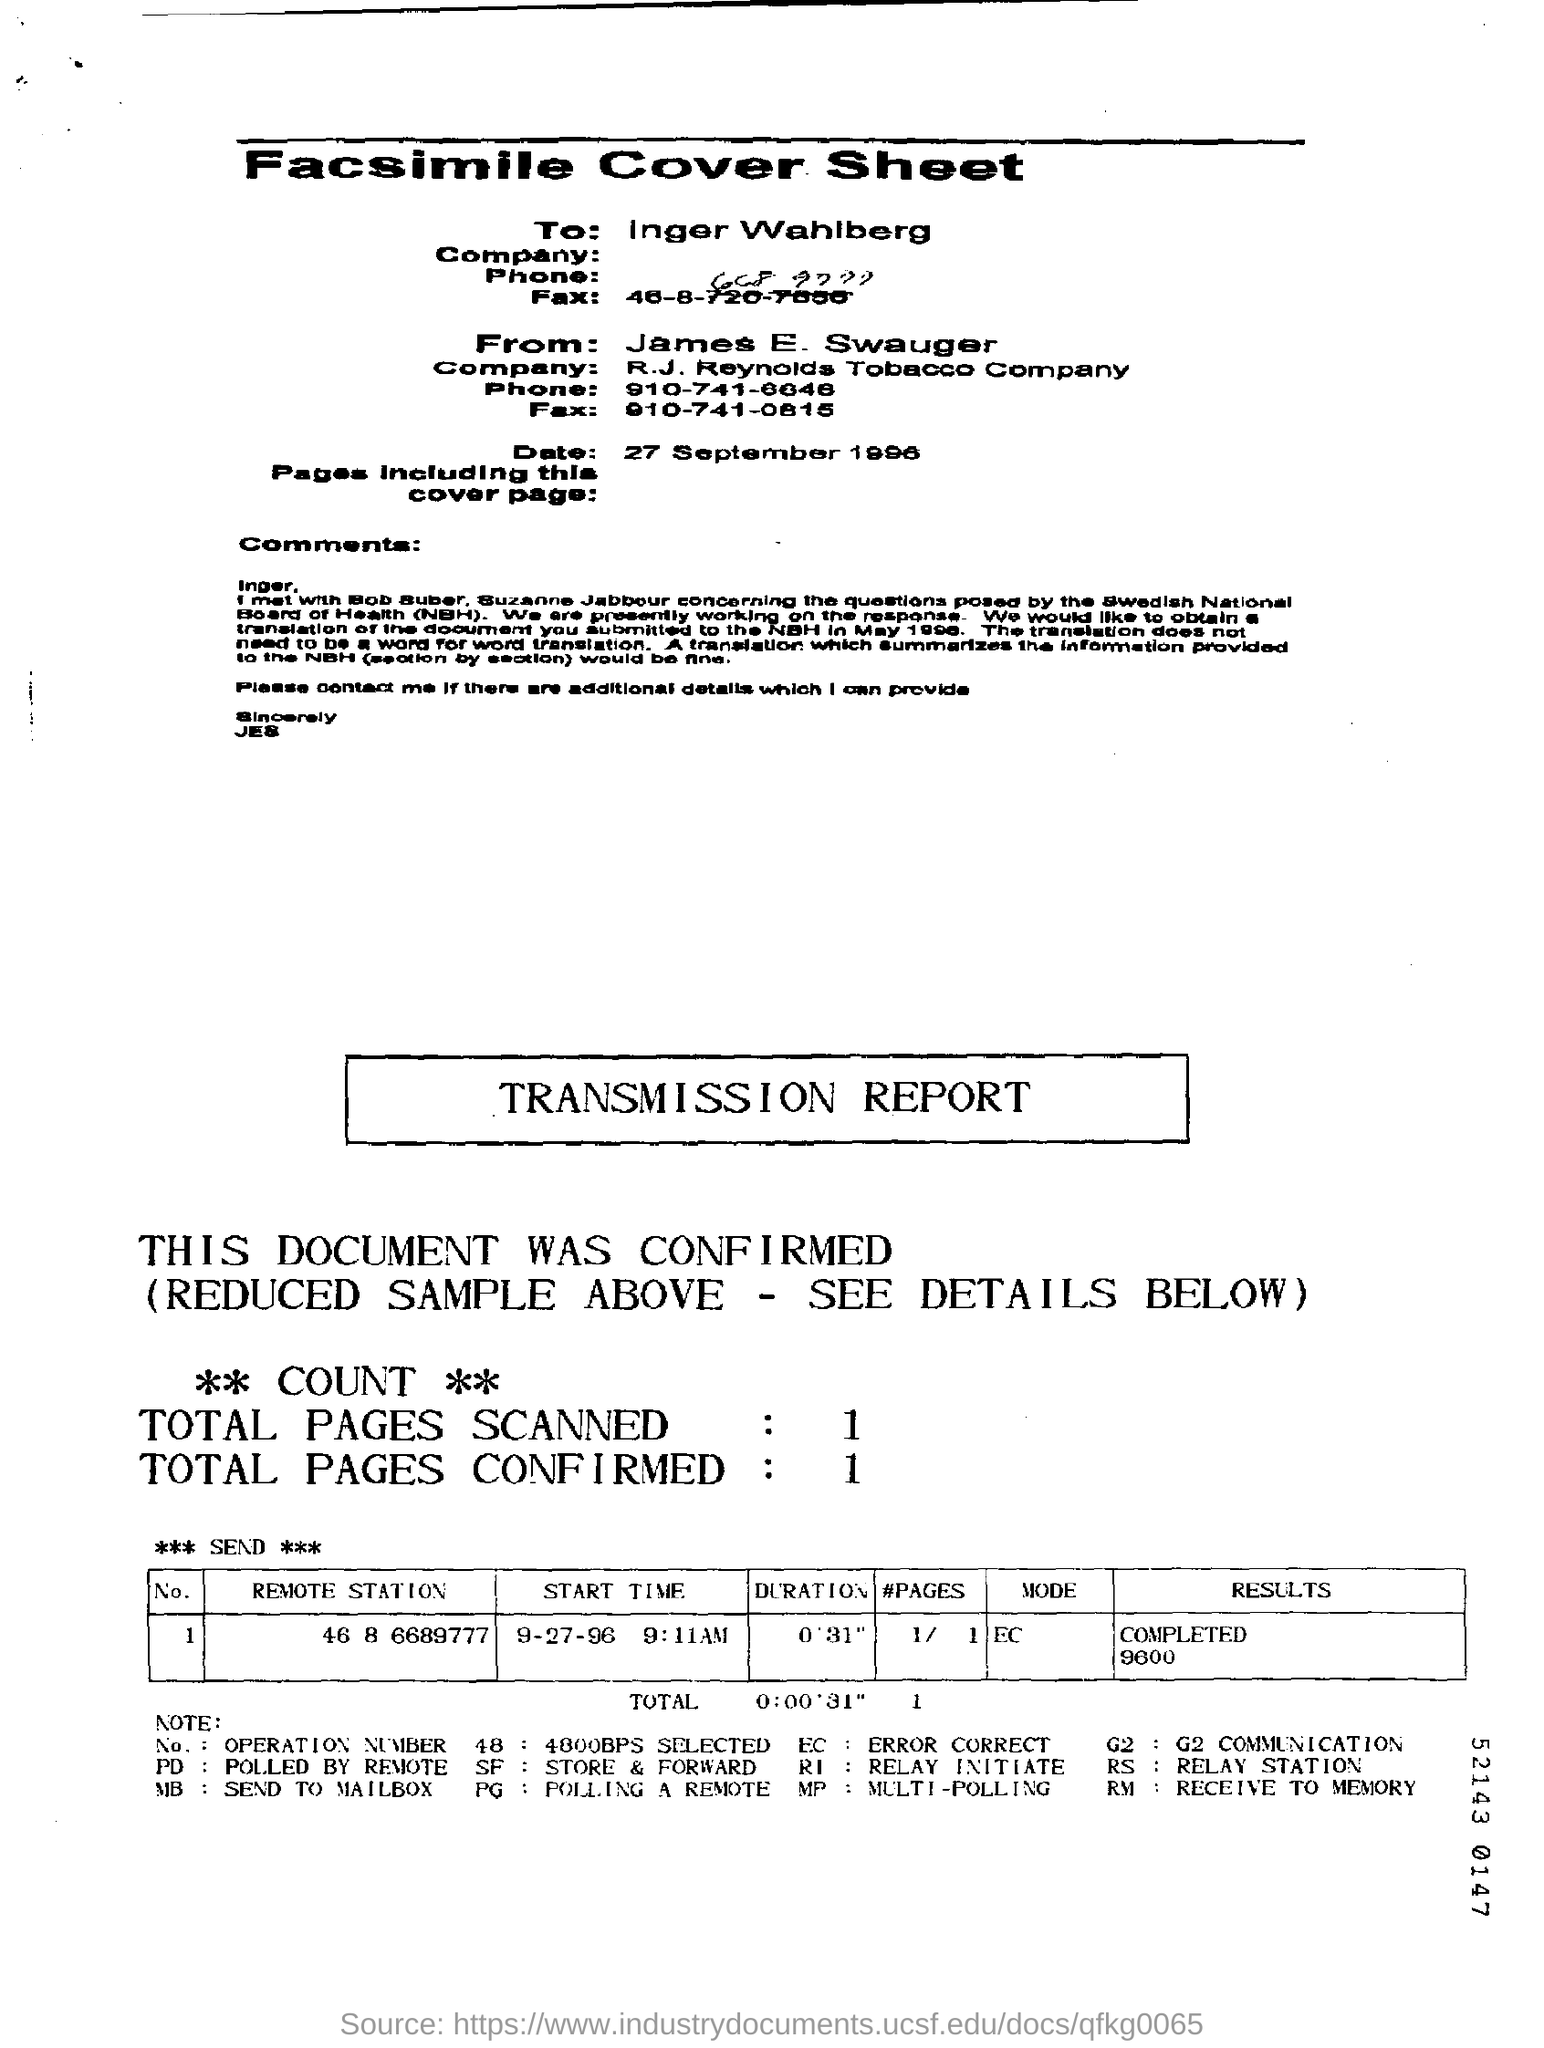What is the date mentioned in the cover sheet ?
Ensure brevity in your answer.  27 september 1996. How many total pages are scanned in the transmission report ?
Give a very brief answer. 1. How many total pages are confirmed in the transmission report ?
Ensure brevity in your answer.  1. What is the duration mentioned in the transmission report ?
Your response must be concise. 0' 31". 